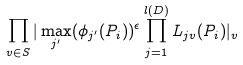<formula> <loc_0><loc_0><loc_500><loc_500>\prod _ { v \in S } | \max _ { j ^ { \prime } } ( \phi _ { j ^ { \prime } } ( P _ { i } ) ) ^ { \epsilon } \prod _ { j = 1 } ^ { l ( D ) } L _ { j v } ( P _ { i } ) | _ { v }</formula> 